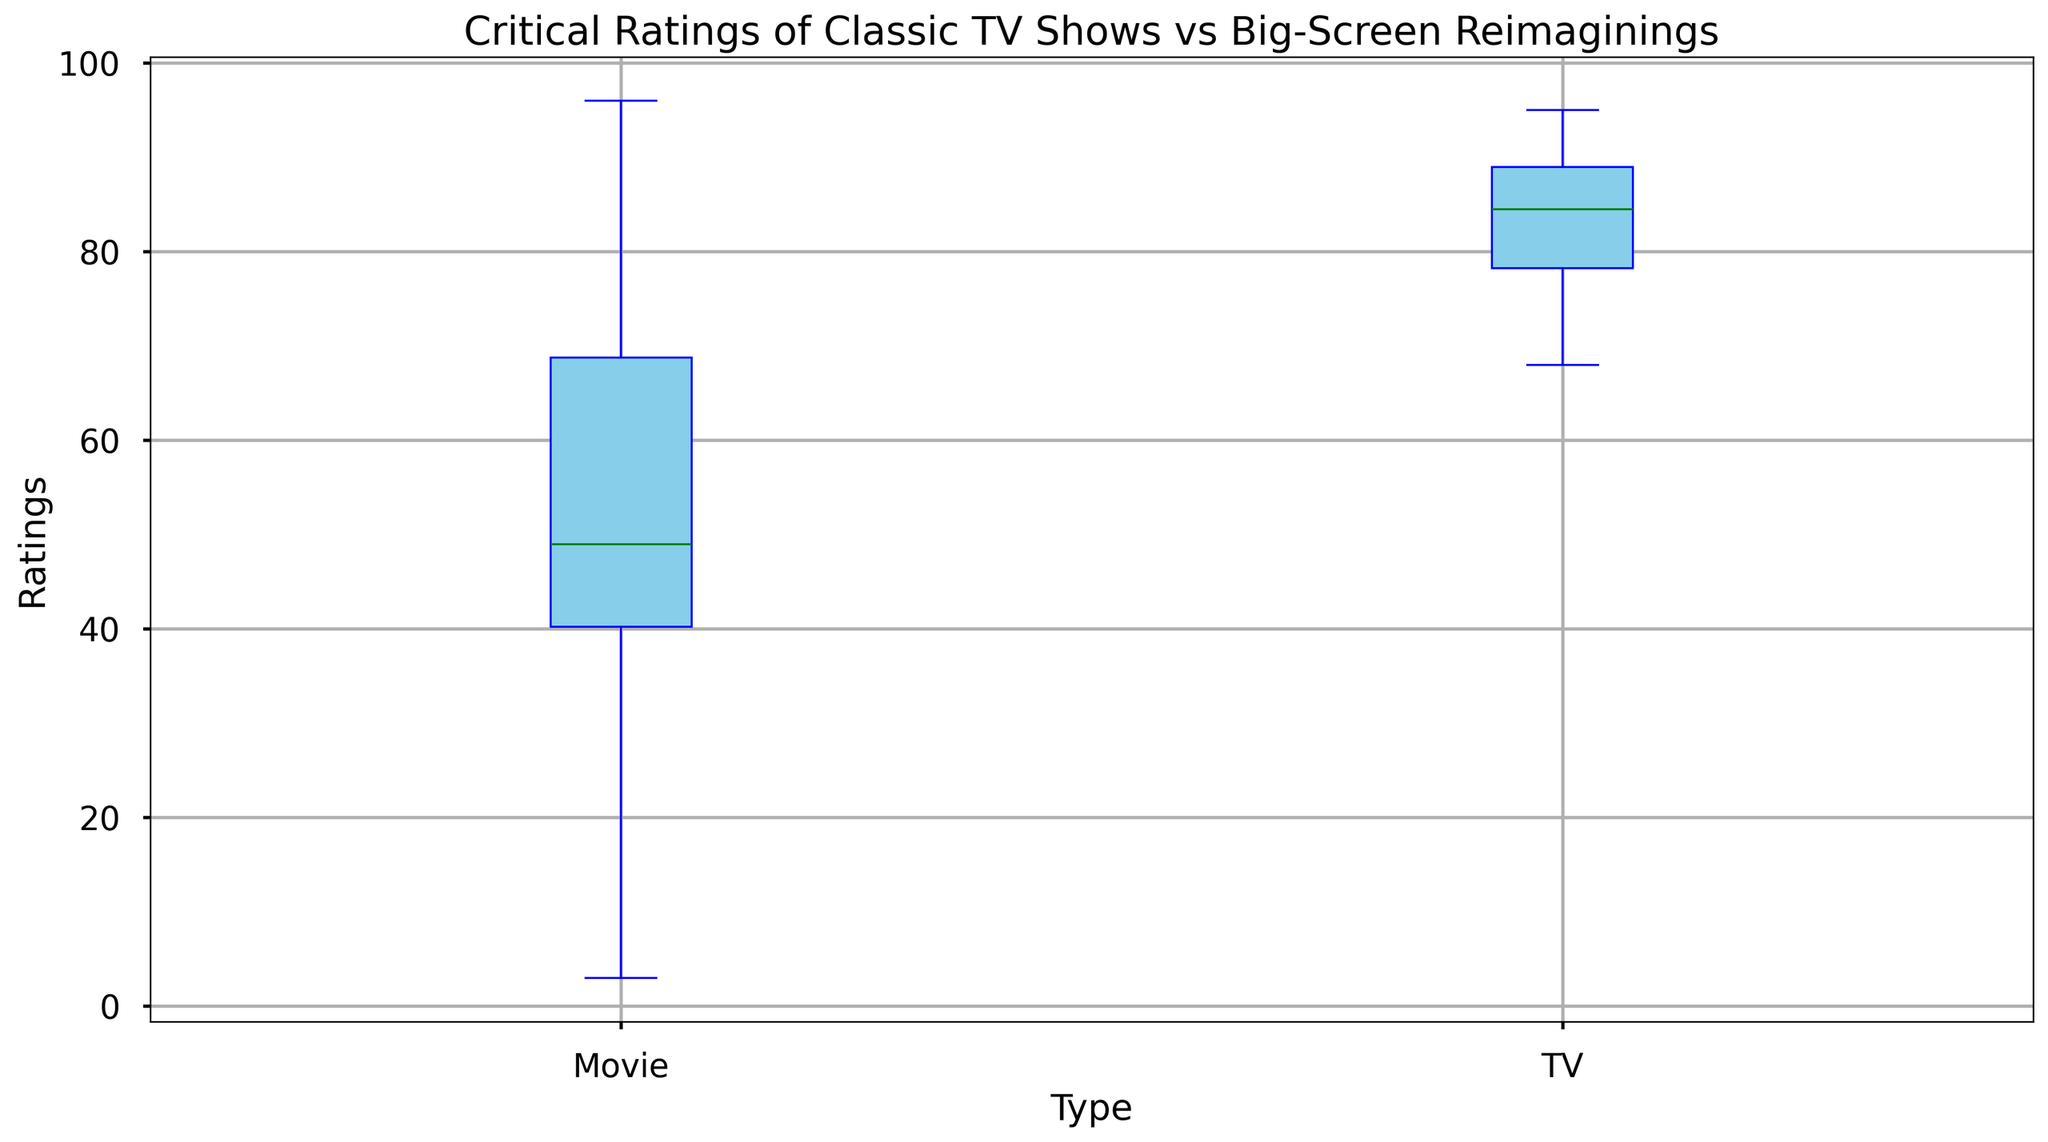Which type has a higher median rating? To find the median rating for each type, look at the horizontal line inside each box that represents the median value. Compare the position of the lines within the boxes.
Answer: TV How much higher is the median rating of TV shows compared to movies? Identify the median values for both TV shows and movies. Subtract the median rating of movies from the median rating of TV shows.
Answer: 34 Are there any TV shows or movies with outliers? What are they? An outlier is a data point that lies outside the range of the whiskers in a box plot. Check outside the whiskers for any individual points.
Answer: Yes, the lowest rating for a movie and the highest rating for a TV show are outliers What's the range of ratings for TV shows? The range is the difference between the maximum and minimum values within the whiskers. Identify these values for TV shows and subtract the lowest from the highest.
Answer: 95 - 68 = 27 What's the range of ratings for movies? The range for movies is obtained by subtracting the minimum rating value within the whiskers from the maximum rating value within the whiskers. Identify these values for movies and compute the difference.
Answer: 96 - 9 = 87 Which has greater variability in ratings, TV shows or movies? Variability is indicated by the length of the box and whiskers. Compare the total length of the whiskers and the box for TV shows and movies.
Answer: Movies Is the median rating of the lowest-rated TV shows higher than the highest-rated movies? Compare the median line of the lowest-rated TV shows box plot to the top whisker of the movies box plot.
Answer: Yes What color represents TV shows in the box plot? Look at the legend or the color of the box corresponding to TV shows.
Answer: Skyblue What color represents movies in the box plot? Look at the legend or the color of the box corresponding to movies.
Answer: Lightcoral How does the interquartile range (IQR) of TV shows compare to that of movies? The interquartile range is represented by the length of the box, from the lower quartile (Q1) to the upper quartile (Q3). Compare this length between TV shows and movies.
Answer: TV shows have a smaller IQR 